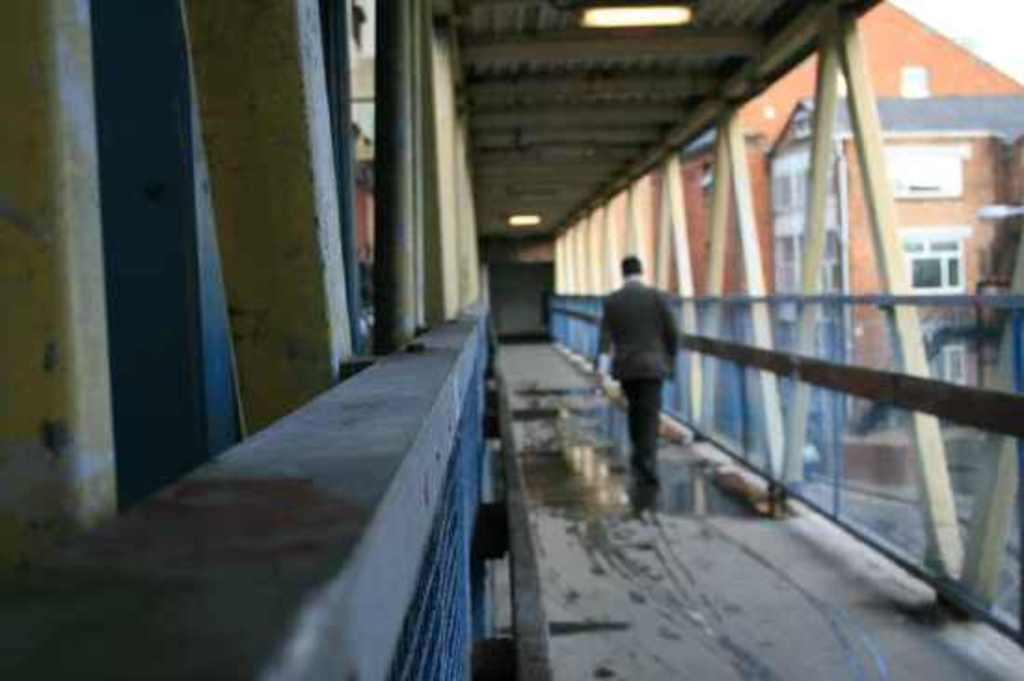Who is present in the image? There is a man in the image. What is the man doing in the image? The man is walking on the floor in the image. What can be seen in the background of the image? There is a building in the image. How many geese are flying over the building in the image? There are no geese present in the image; it only features a man walking on the floor and a building in the background. 